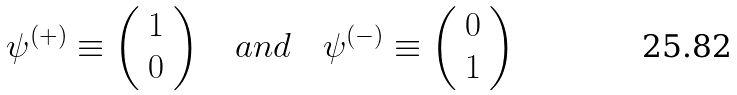Convert formula to latex. <formula><loc_0><loc_0><loc_500><loc_500>\psi ^ { ( + ) } \equiv \left ( \begin{array} { c } 1 \\ 0 \end{array} \right ) \quad a n d \quad \psi ^ { ( - ) } \equiv \left ( \begin{array} { c } 0 \\ 1 \end{array} \right )</formula> 